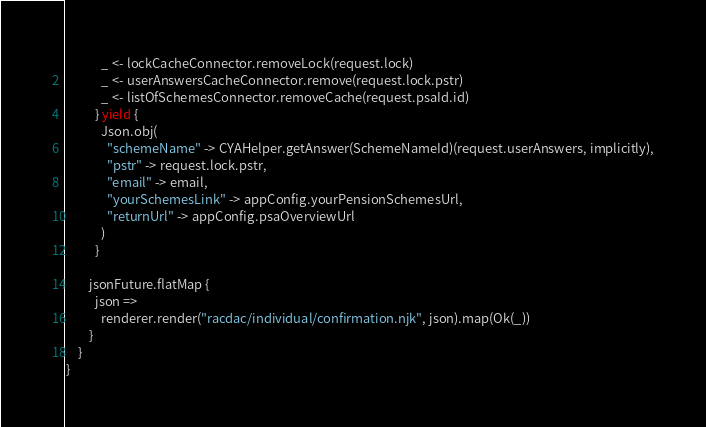Convert code to text. <code><loc_0><loc_0><loc_500><loc_500><_Scala_>            _ <- lockCacheConnector.removeLock(request.lock)
            _ <- userAnswersCacheConnector.remove(request.lock.pstr)
            _ <- listOfSchemesConnector.removeCache(request.psaId.id)
          } yield {
            Json.obj(
              "schemeName" -> CYAHelper.getAnswer(SchemeNameId)(request.userAnswers, implicitly),
              "pstr" -> request.lock.pstr,
              "email" -> email,
              "yourSchemesLink" -> appConfig.yourPensionSchemesUrl,
              "returnUrl" -> appConfig.psaOverviewUrl
            )
          }

        jsonFuture.flatMap {
          json =>
            renderer.render("racdac/individual/confirmation.njk", json).map(Ok(_))
        }
    }
}
</code> 